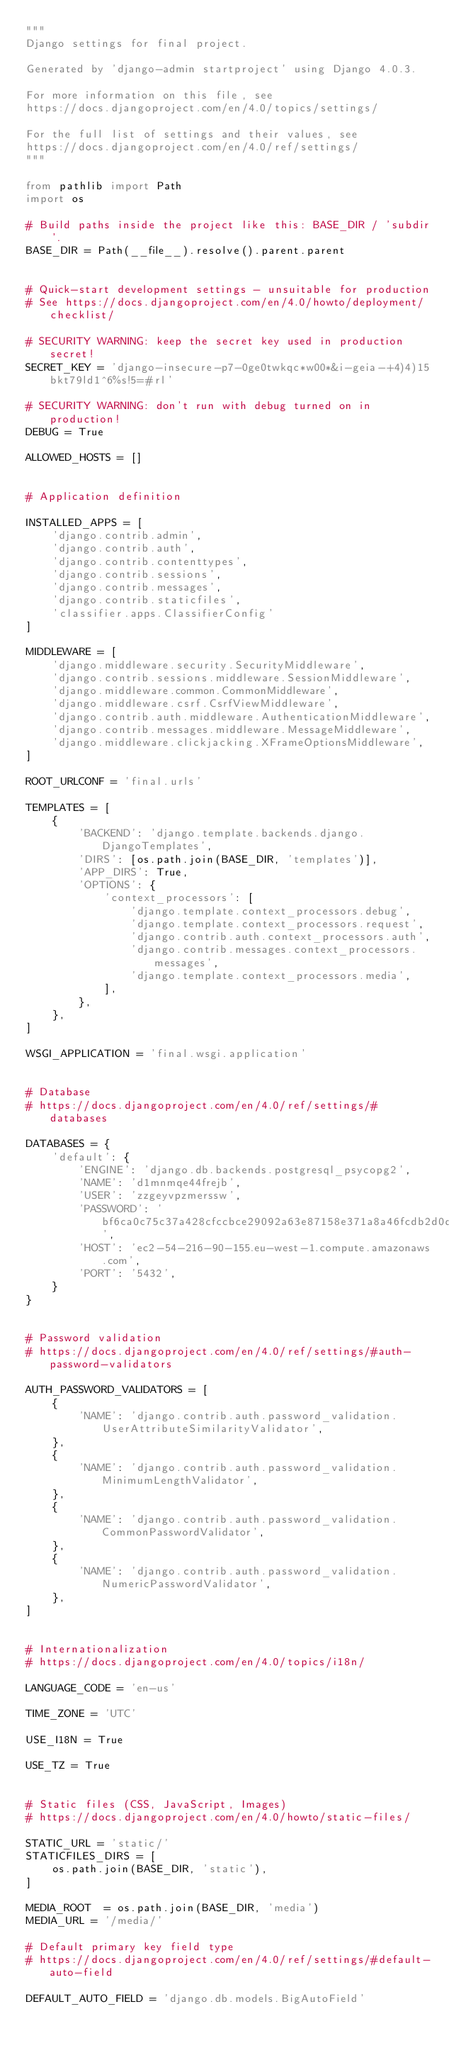<code> <loc_0><loc_0><loc_500><loc_500><_Python_>"""
Django settings for final project.

Generated by 'django-admin startproject' using Django 4.0.3.

For more information on this file, see
https://docs.djangoproject.com/en/4.0/topics/settings/

For the full list of settings and their values, see
https://docs.djangoproject.com/en/4.0/ref/settings/
"""

from pathlib import Path
import os

# Build paths inside the project like this: BASE_DIR / 'subdir'.
BASE_DIR = Path(__file__).resolve().parent.parent


# Quick-start development settings - unsuitable for production
# See https://docs.djangoproject.com/en/4.0/howto/deployment/checklist/

# SECURITY WARNING: keep the secret key used in production secret!
SECRET_KEY = 'django-insecure-p7-0ge0twkqc*w00*&i-geia-+4)4)15bkt79ld1^6%s!5=#rl'

# SECURITY WARNING: don't run with debug turned on in production!
DEBUG = True

ALLOWED_HOSTS = []


# Application definition

INSTALLED_APPS = [
    'django.contrib.admin',
    'django.contrib.auth',
    'django.contrib.contenttypes',
    'django.contrib.sessions',
    'django.contrib.messages',
    'django.contrib.staticfiles',
    'classifier.apps.ClassifierConfig'
]

MIDDLEWARE = [
    'django.middleware.security.SecurityMiddleware',
    'django.contrib.sessions.middleware.SessionMiddleware',
    'django.middleware.common.CommonMiddleware',
    'django.middleware.csrf.CsrfViewMiddleware',
    'django.contrib.auth.middleware.AuthenticationMiddleware',
    'django.contrib.messages.middleware.MessageMiddleware',
    'django.middleware.clickjacking.XFrameOptionsMiddleware',
]

ROOT_URLCONF = 'final.urls'

TEMPLATES = [
    {
        'BACKEND': 'django.template.backends.django.DjangoTemplates',
        'DIRS': [os.path.join(BASE_DIR, 'templates')],
        'APP_DIRS': True,
        'OPTIONS': {
            'context_processors': [
                'django.template.context_processors.debug',
                'django.template.context_processors.request',
                'django.contrib.auth.context_processors.auth',
                'django.contrib.messages.context_processors.messages',
                'django.template.context_processors.media',
            ],
        },
    },
]

WSGI_APPLICATION = 'final.wsgi.application'


# Database
# https://docs.djangoproject.com/en/4.0/ref/settings/#databases

DATABASES = {
    'default': {
        'ENGINE': 'django.db.backends.postgresql_psycopg2',
        'NAME': 'd1mnmqe44frejb',
        'USER': 'zzgeyvpzmerssw',
        'PASSWORD': 'bf6ca0c75c37a428cfccbce29092a63e87158e371a8a46fcdb2d0d2db31a77c0',
        'HOST': 'ec2-54-216-90-155.eu-west-1.compute.amazonaws.com',
        'PORT': '5432',
    }
}


# Password validation
# https://docs.djangoproject.com/en/4.0/ref/settings/#auth-password-validators

AUTH_PASSWORD_VALIDATORS = [
    {
        'NAME': 'django.contrib.auth.password_validation.UserAttributeSimilarityValidator',
    },
    {
        'NAME': 'django.contrib.auth.password_validation.MinimumLengthValidator',
    },
    {
        'NAME': 'django.contrib.auth.password_validation.CommonPasswordValidator',
    },
    {
        'NAME': 'django.contrib.auth.password_validation.NumericPasswordValidator',
    },
]


# Internationalization
# https://docs.djangoproject.com/en/4.0/topics/i18n/

LANGUAGE_CODE = 'en-us'

TIME_ZONE = 'UTC'

USE_I18N = True

USE_TZ = True


# Static files (CSS, JavaScript, Images)
# https://docs.djangoproject.com/en/4.0/howto/static-files/

STATIC_URL = 'static/'
STATICFILES_DIRS = [
    os.path.join(BASE_DIR, 'static'),
]

MEDIA_ROOT  = os.path.join(BASE_DIR, 'media')
MEDIA_URL = '/media/'

# Default primary key field type
# https://docs.djangoproject.com/en/4.0/ref/settings/#default-auto-field

DEFAULT_AUTO_FIELD = 'django.db.models.BigAutoField'
</code> 